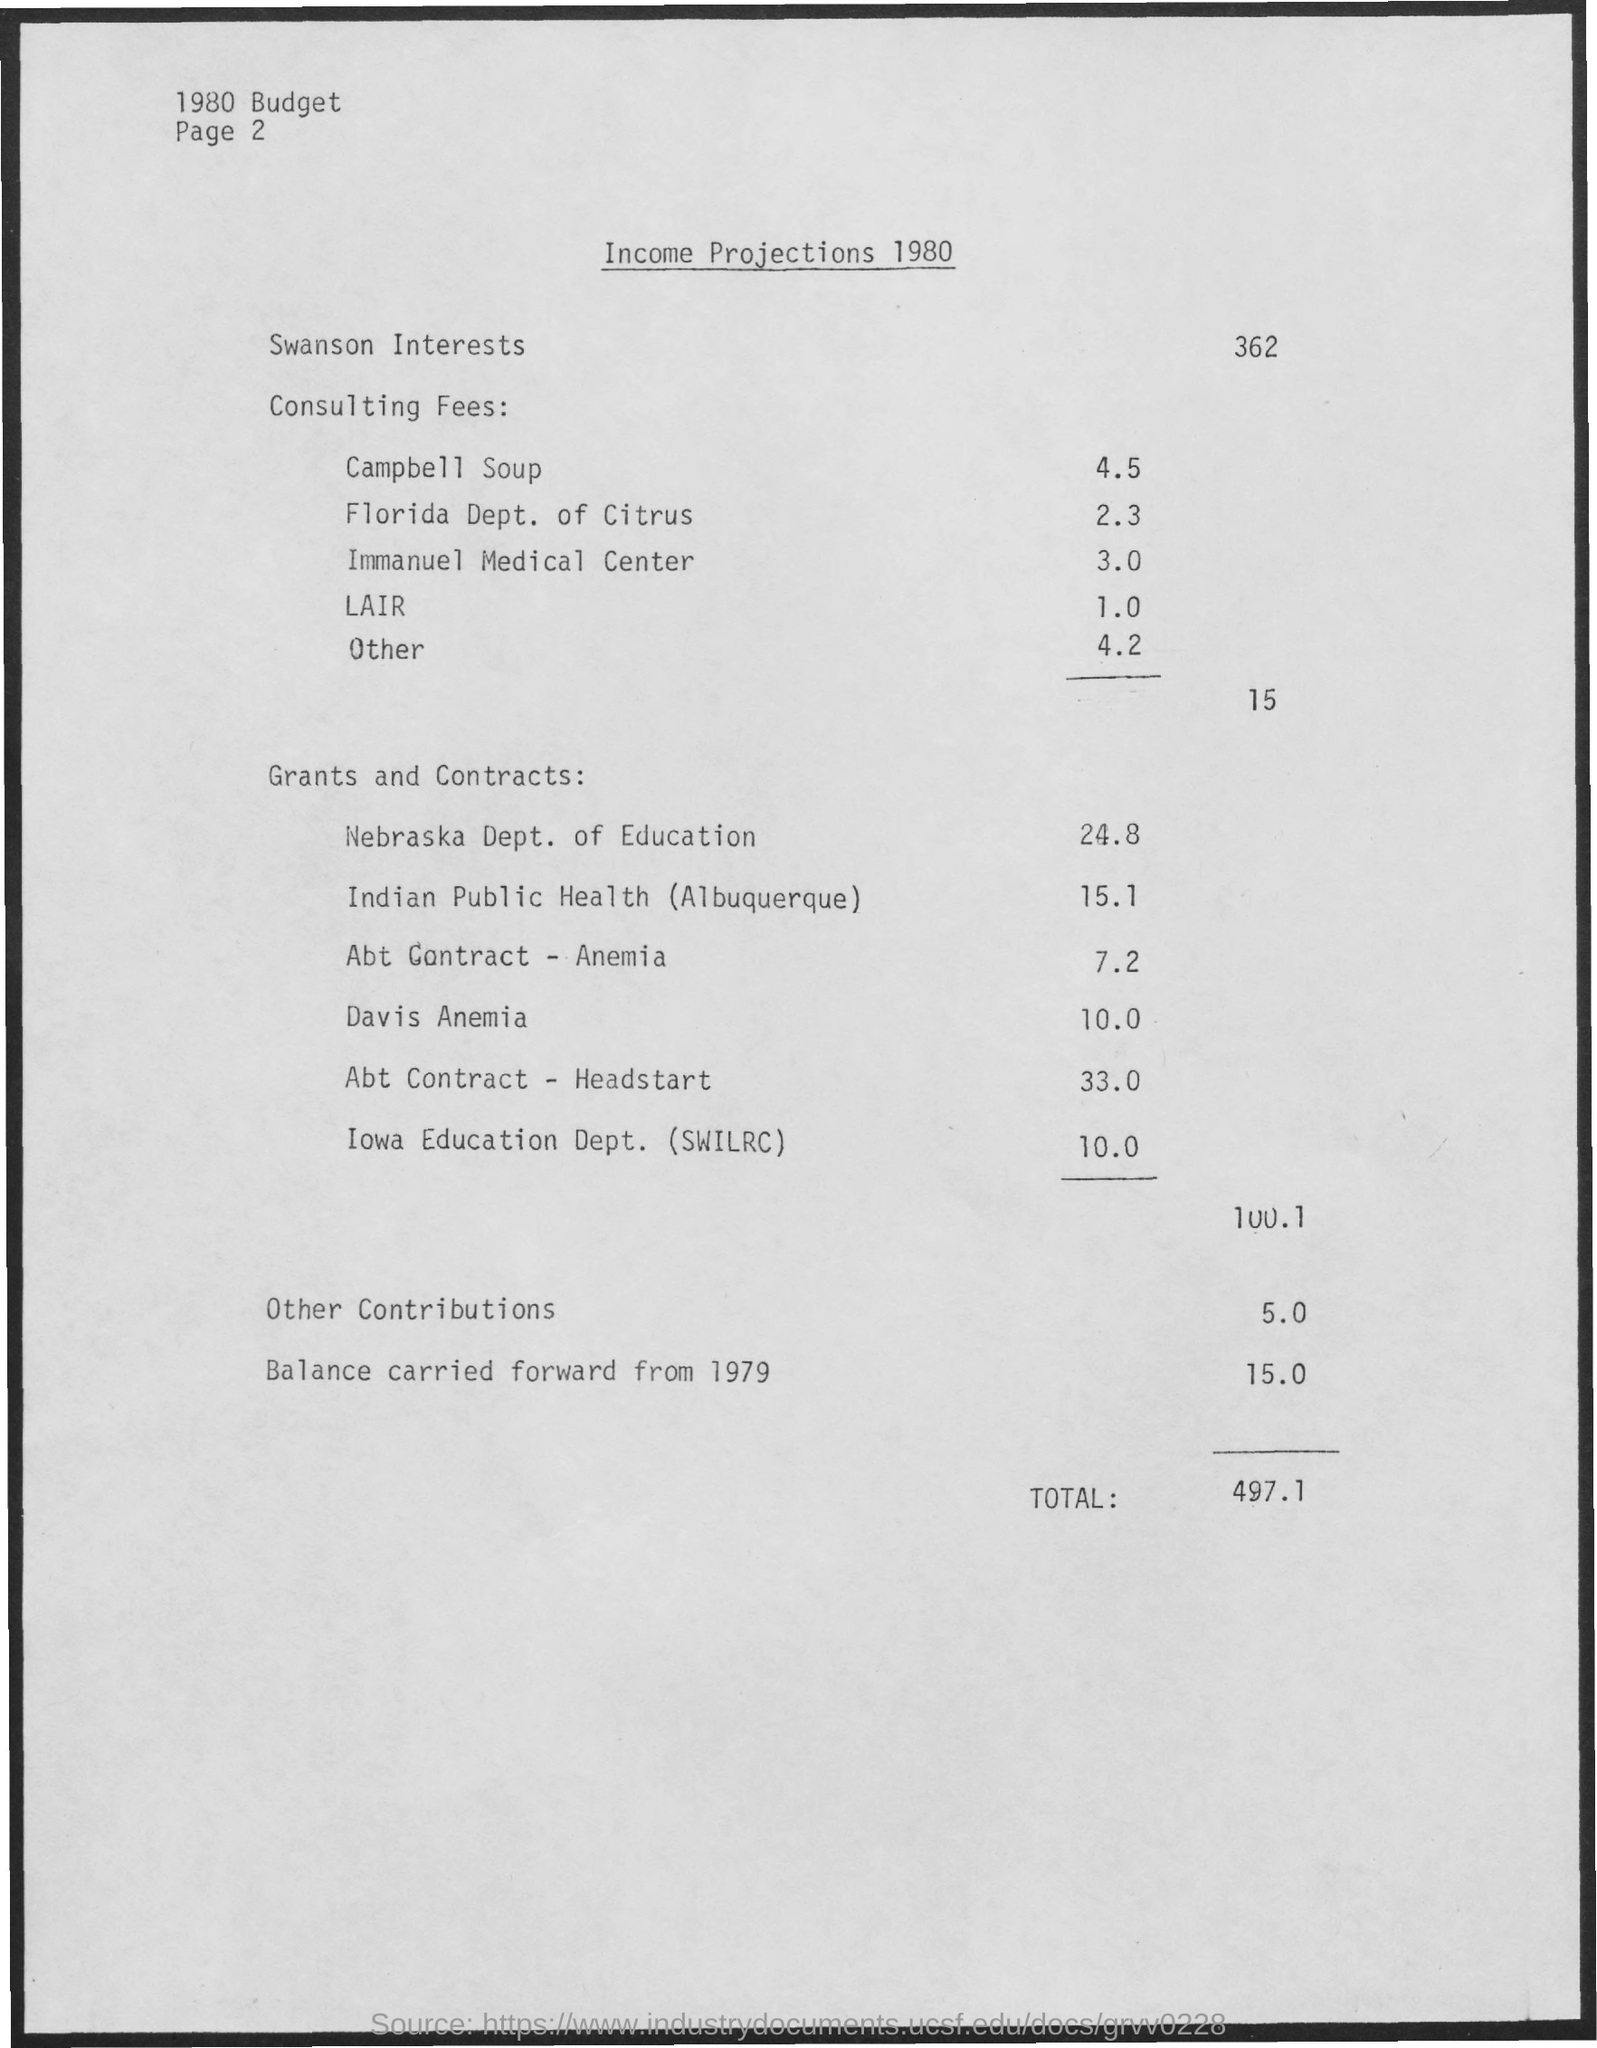What is the amount mentioned for swanson interests ?
Make the answer very short. 362. What is the amount mentioned for campbell soup ?
Your response must be concise. 4.5. What is the amount mentioned for florida dept. of citrus ?
Provide a short and direct response. 2.3. What is the amount of income mentioned for nebraska dept. of education ?
Provide a short and direct response. 24.8. What is the total income mentioned ?
Your answer should be very brief. 497.1. What is the income mentioned for other contributions ?
Provide a succinct answer. 5.0. What is the income of balance carried forward from 1979 ?
Your answer should be compact. 15.0. 